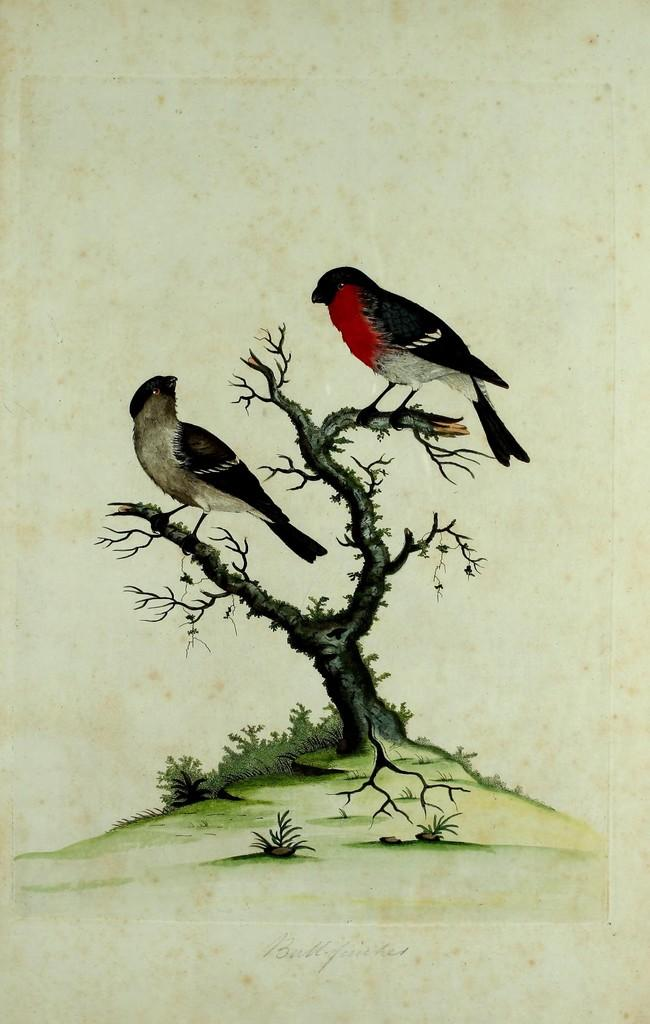What is depicted on the paper in the image? The paper contains an art of a tree. Are there any additional elements in the tree art? Yes, the tree art has 2 birds. What can be seen on the ground in the image? There are plants on the ground in the image. What type of liquid is being poured from the pig's snout in the image? There is no pig or liquid present in the image; it features a paper with tree art and plants on the ground. 